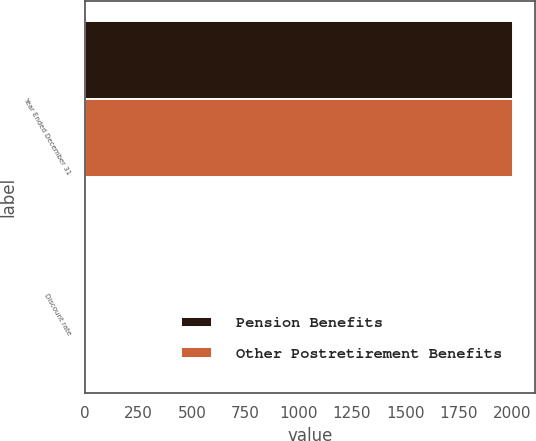Convert chart to OTSL. <chart><loc_0><loc_0><loc_500><loc_500><stacked_bar_chart><ecel><fcel>Year Ended December 31<fcel>Discount rate<nl><fcel>Pension Benefits<fcel>2007<fcel>5.7<nl><fcel>Other Postretirement Benefits<fcel>2007<fcel>5.6<nl></chart> 